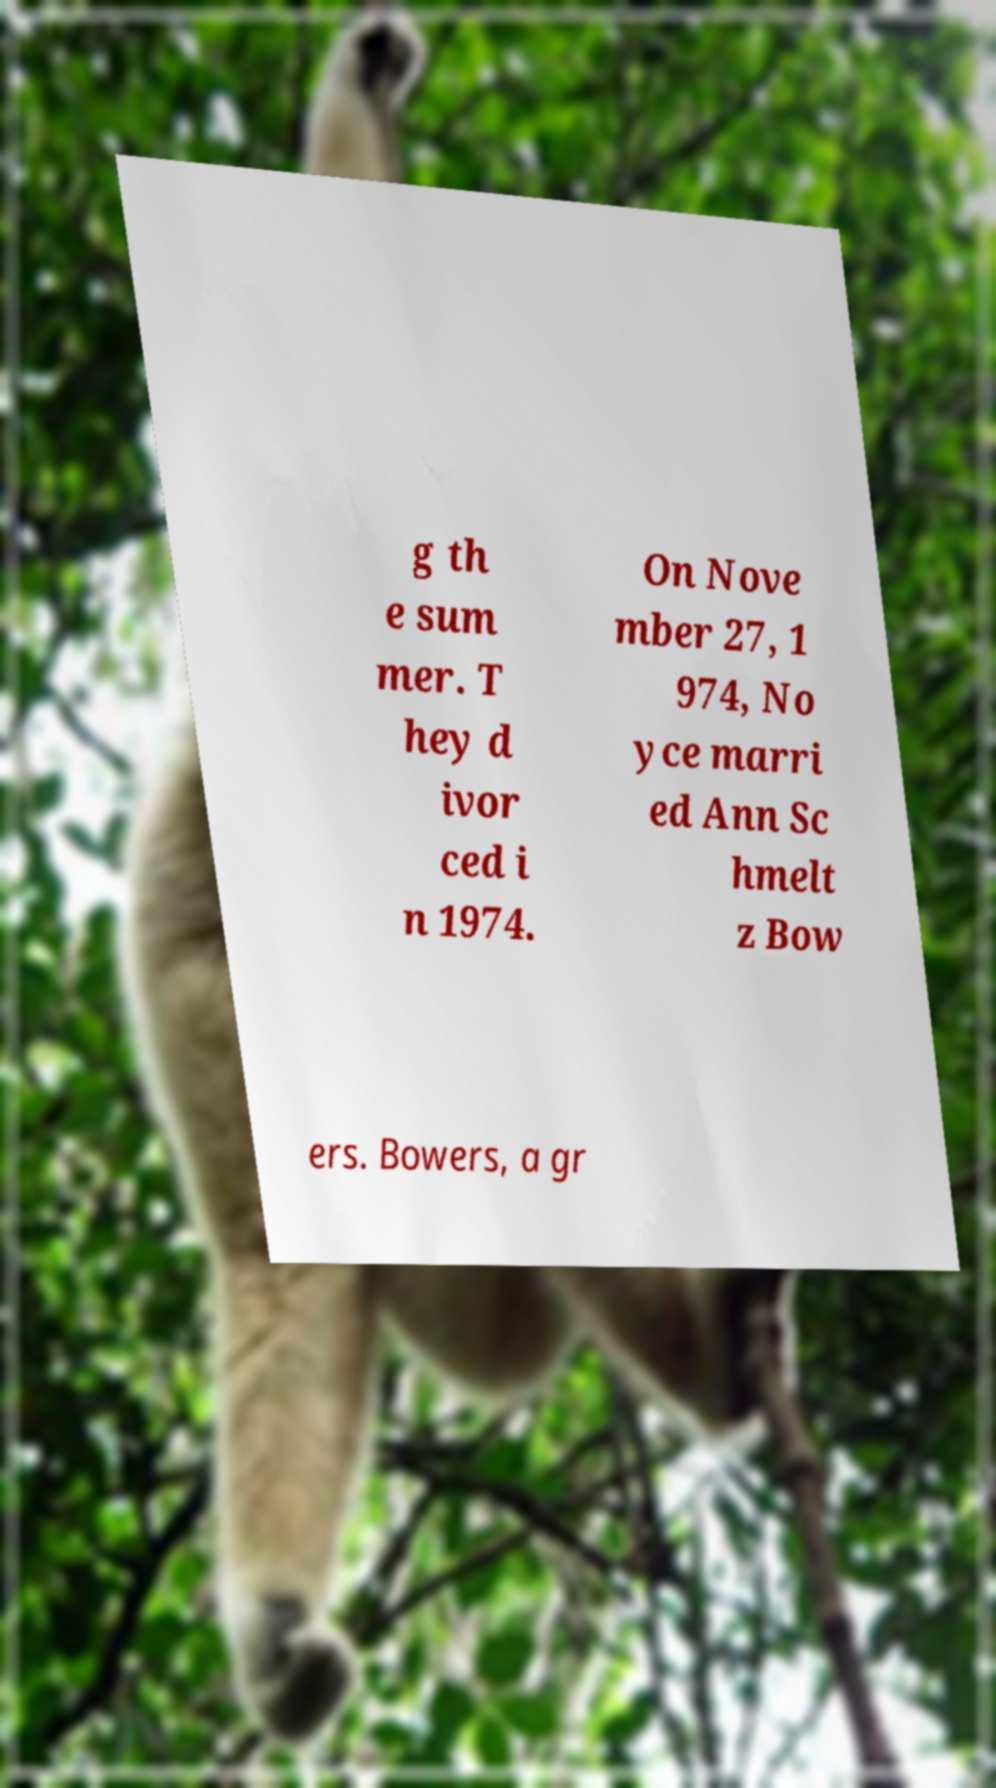Can you accurately transcribe the text from the provided image for me? g th e sum mer. T hey d ivor ced i n 1974. On Nove mber 27, 1 974, No yce marri ed Ann Sc hmelt z Bow ers. Bowers, a gr 